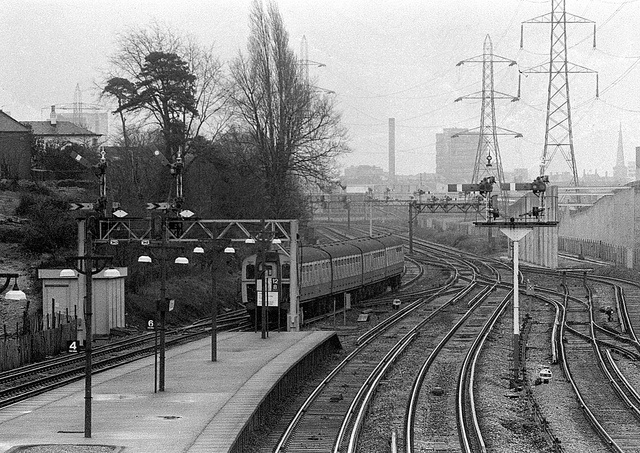Describe the objects in this image and their specific colors. I can see a train in white, gray, black, darkgray, and lightgray tones in this image. 